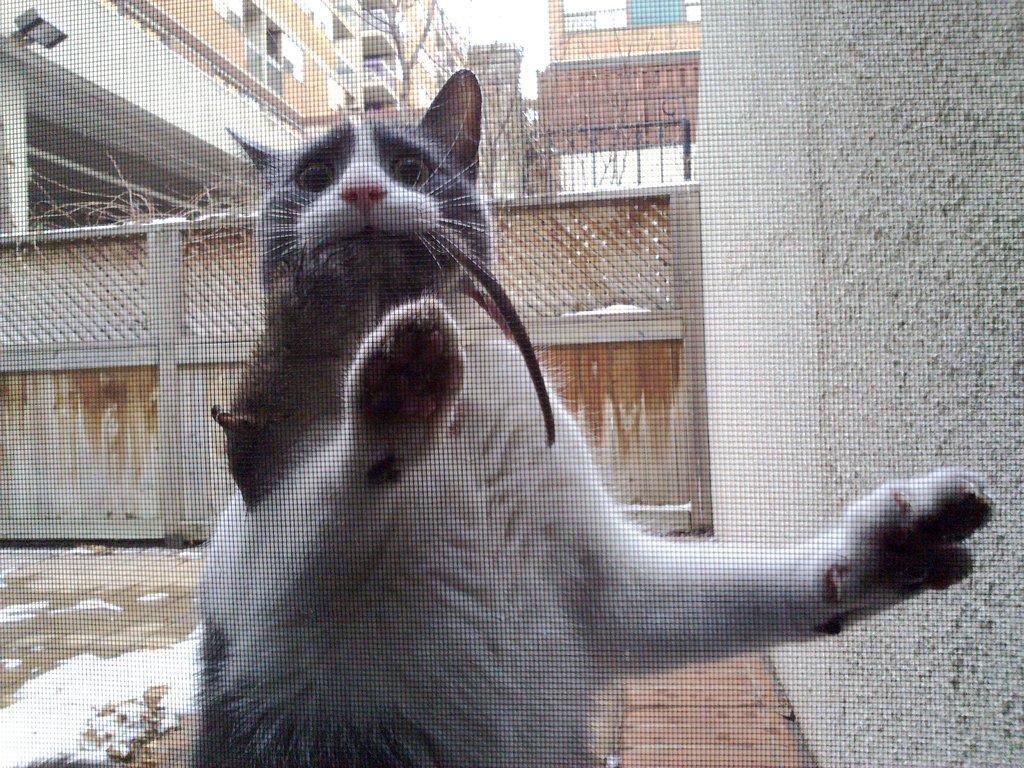Please provide a concise description of this image. In this image there is a cat, in the background there is a gate and buildings, on the right side there is a wall. 